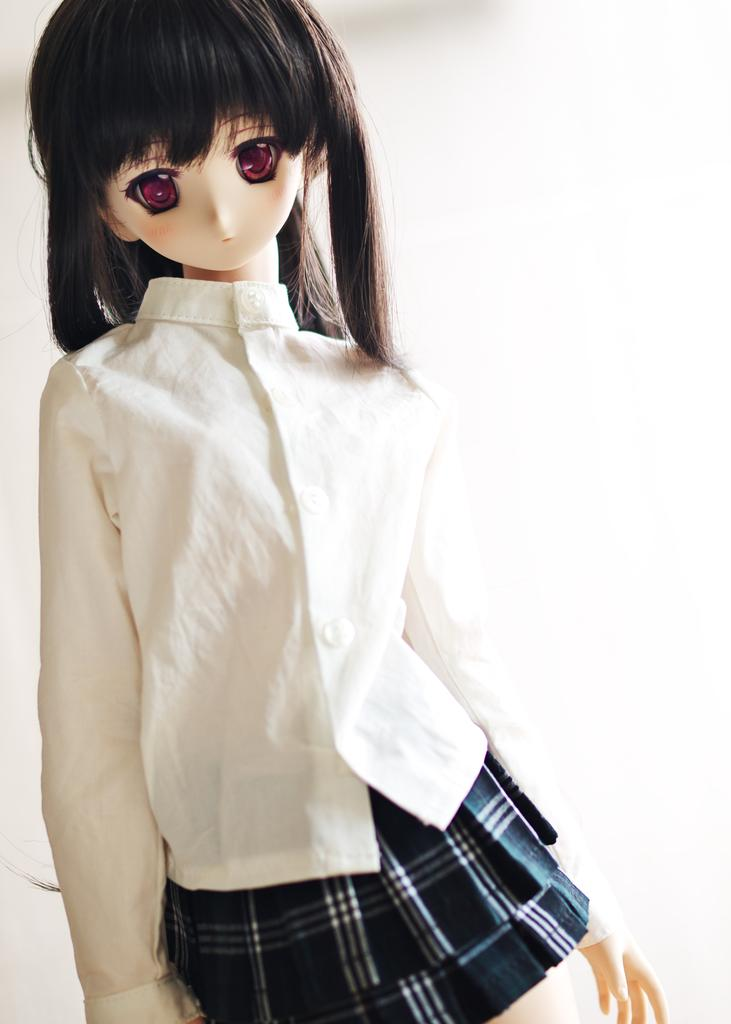What is the main subject of the image? There is a doll in the image. What is the doll wearing on its upper body? The doll is wearing a white shirt. What is the doll wearing on its lower body? The doll is wearing a blue skirt. What type of ornament is hanging from the doll's neck in the image? There is no ornament hanging from the doll's neck in the image; the doll is only wearing a white shirt and a blue skirt. 